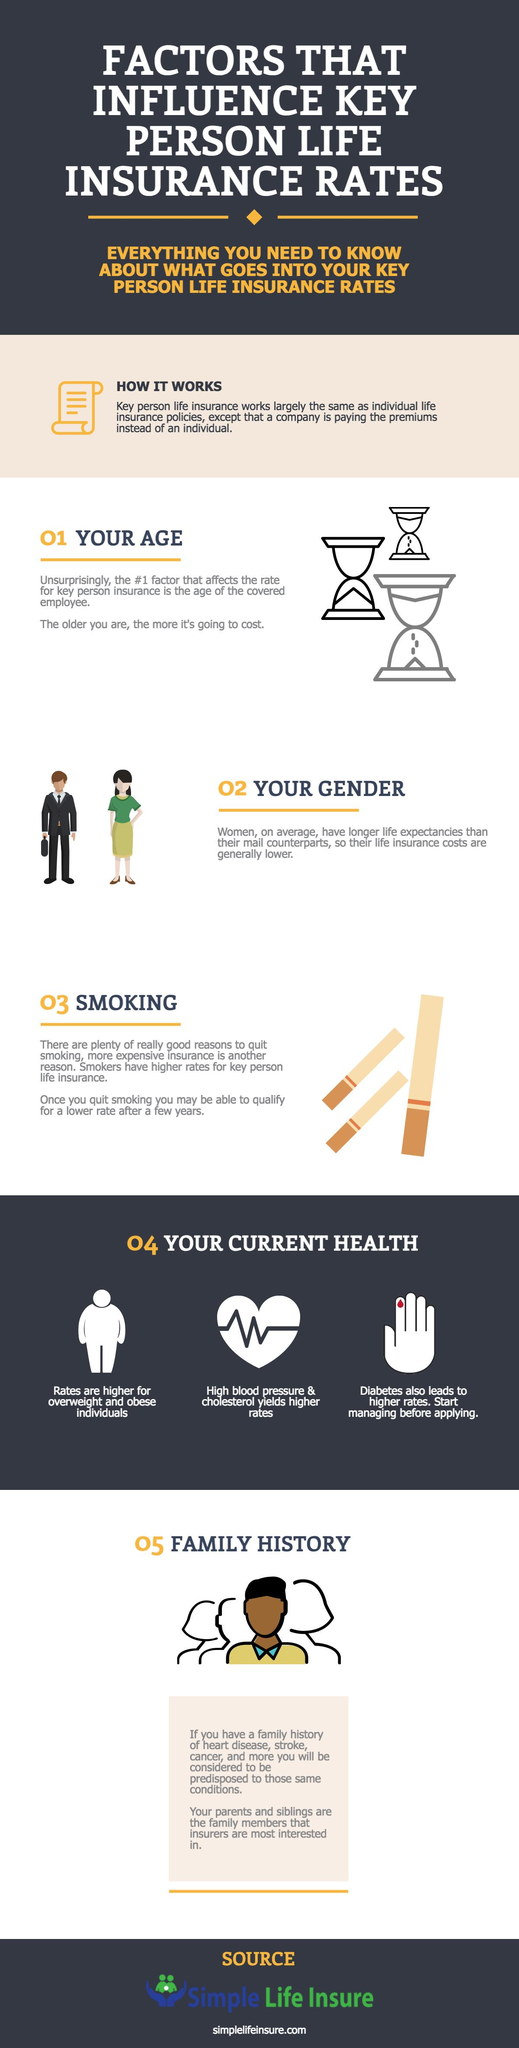Outline some significant characteristics in this image. The third condition mentioned in Current Health that may result in higher insurance rates is diabetes. Women typically have lower insurance costs compared to men. Non-smokers are likely to have the lowest insurance rates compared to smokers and individuals who have recently quit smoking. According to the factors under Current Health, individuals who are overweight or obese are typically subject to higher rates. Key person life insurance is a type of insurance policy in which a company pays the premiums for the policy, which provides coverage in the event that a key employee dies or becomes unable to work due to illness or injury. 